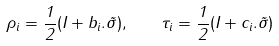<formula> <loc_0><loc_0><loc_500><loc_500>\rho _ { i } = \frac { 1 } { 2 } ( I + b _ { i } . \vec { \sigma } ) , \quad \tau _ { i } = \frac { 1 } { 2 } ( I + c _ { i } . \vec { \sigma } )</formula> 